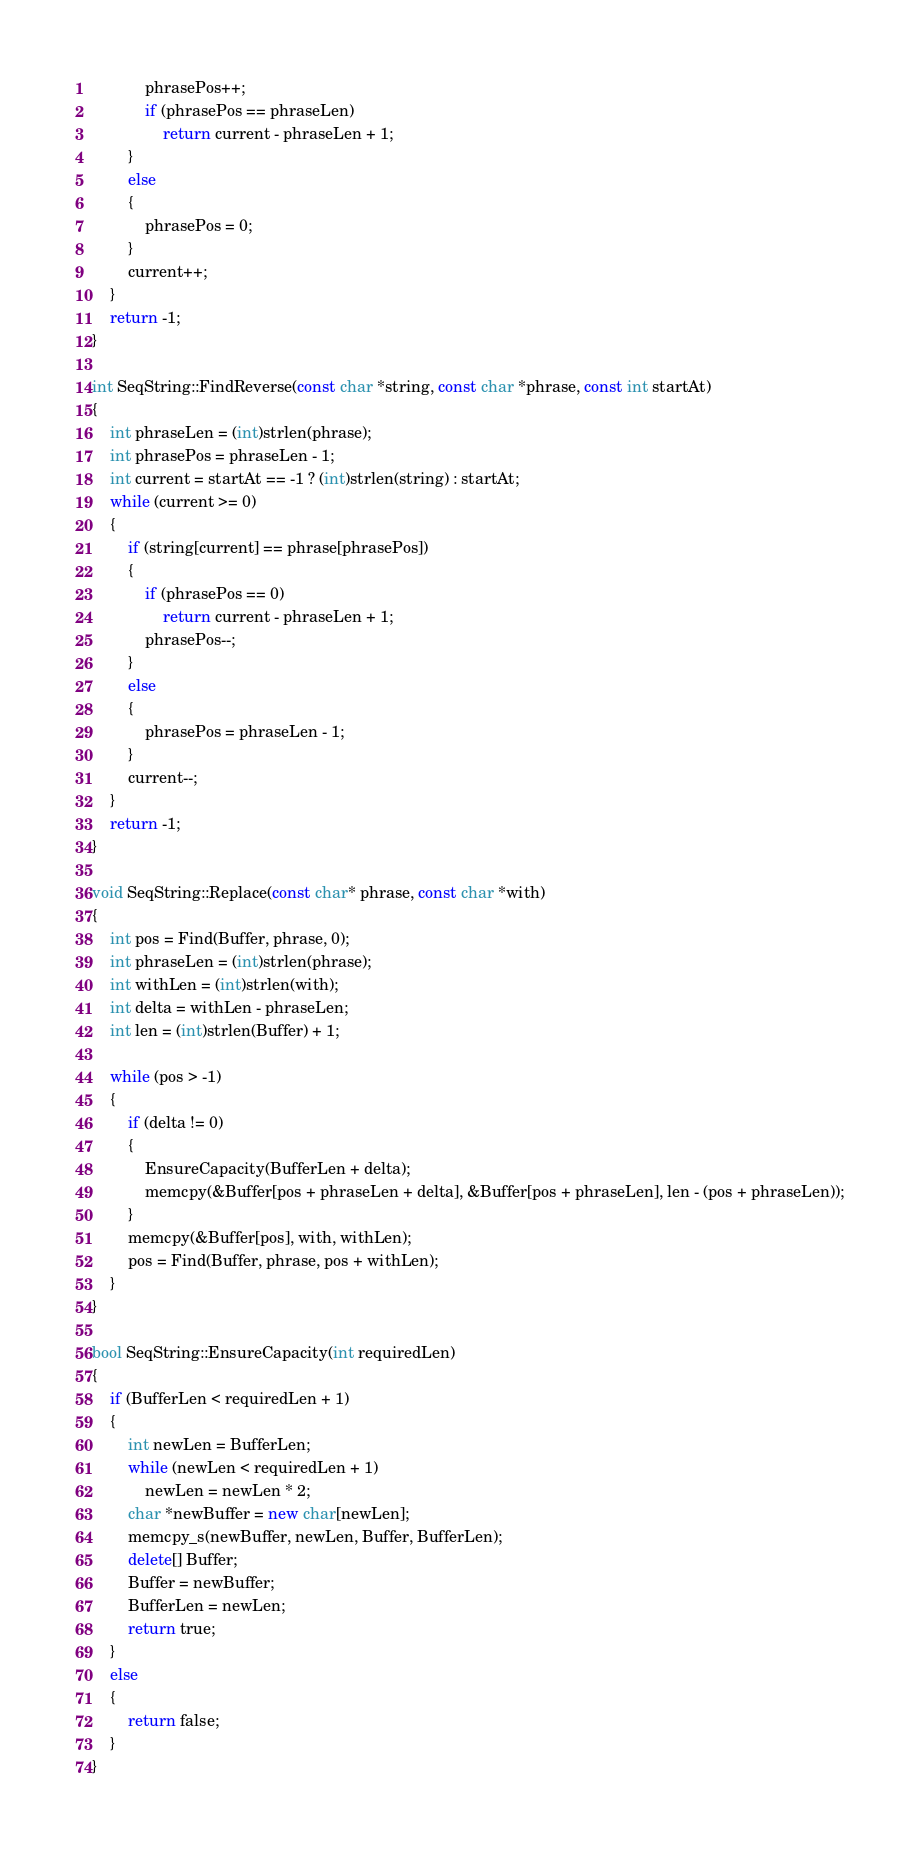Convert code to text. <code><loc_0><loc_0><loc_500><loc_500><_C++_>			phrasePos++;
			if (phrasePos == phraseLen)
				return current - phraseLen + 1;
		}
		else
		{
			phrasePos = 0;
		}
		current++;
	}
	return -1;
}

int SeqString::FindReverse(const char *string, const char *phrase, const int startAt)
{
	int phraseLen = (int)strlen(phrase);
	int phrasePos = phraseLen - 1;
	int current = startAt == -1 ? (int)strlen(string) : startAt;
	while (current >= 0)
	{
		if (string[current] == phrase[phrasePos])
		{
			if (phrasePos == 0)
				return current - phraseLen + 1;
			phrasePos--;
		}
		else
		{
			phrasePos = phraseLen - 1;
		}
		current--;
	}
	return -1;
}

void SeqString::Replace(const char* phrase, const char *with)
{
	int pos = Find(Buffer, phrase, 0);
	int phraseLen = (int)strlen(phrase);
	int withLen = (int)strlen(with);
	int delta = withLen - phraseLen;
	int len = (int)strlen(Buffer) + 1;

	while (pos > -1)
	{
		if (delta != 0)
		{
			EnsureCapacity(BufferLen + delta);
			memcpy(&Buffer[pos + phraseLen + delta], &Buffer[pos + phraseLen], len - (pos + phraseLen));
		}
		memcpy(&Buffer[pos], with, withLen);
		pos = Find(Buffer, phrase, pos + withLen);
	}
}

bool SeqString::EnsureCapacity(int requiredLen)
{
	if (BufferLen < requiredLen + 1)
	{
		int newLen = BufferLen;
		while (newLen < requiredLen + 1)
			newLen = newLen * 2;
		char *newBuffer = new char[newLen];
		memcpy_s(newBuffer, newLen, Buffer, BufferLen);
		delete[] Buffer;
		Buffer = newBuffer;
		BufferLen = newLen;
		return true;
	}
	else
	{
		return false;
	}
}
</code> 